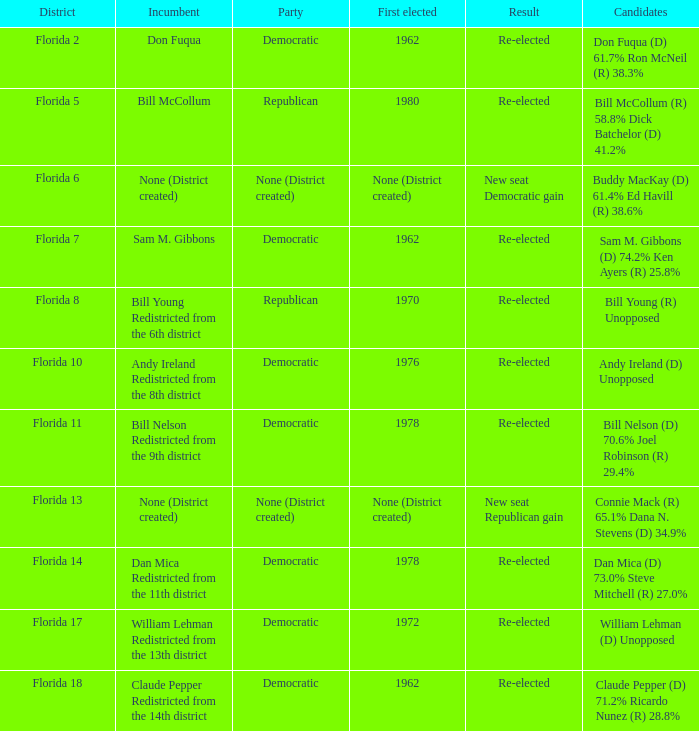Who is the inaugural elected official in florida's district 7? 1962.0. 